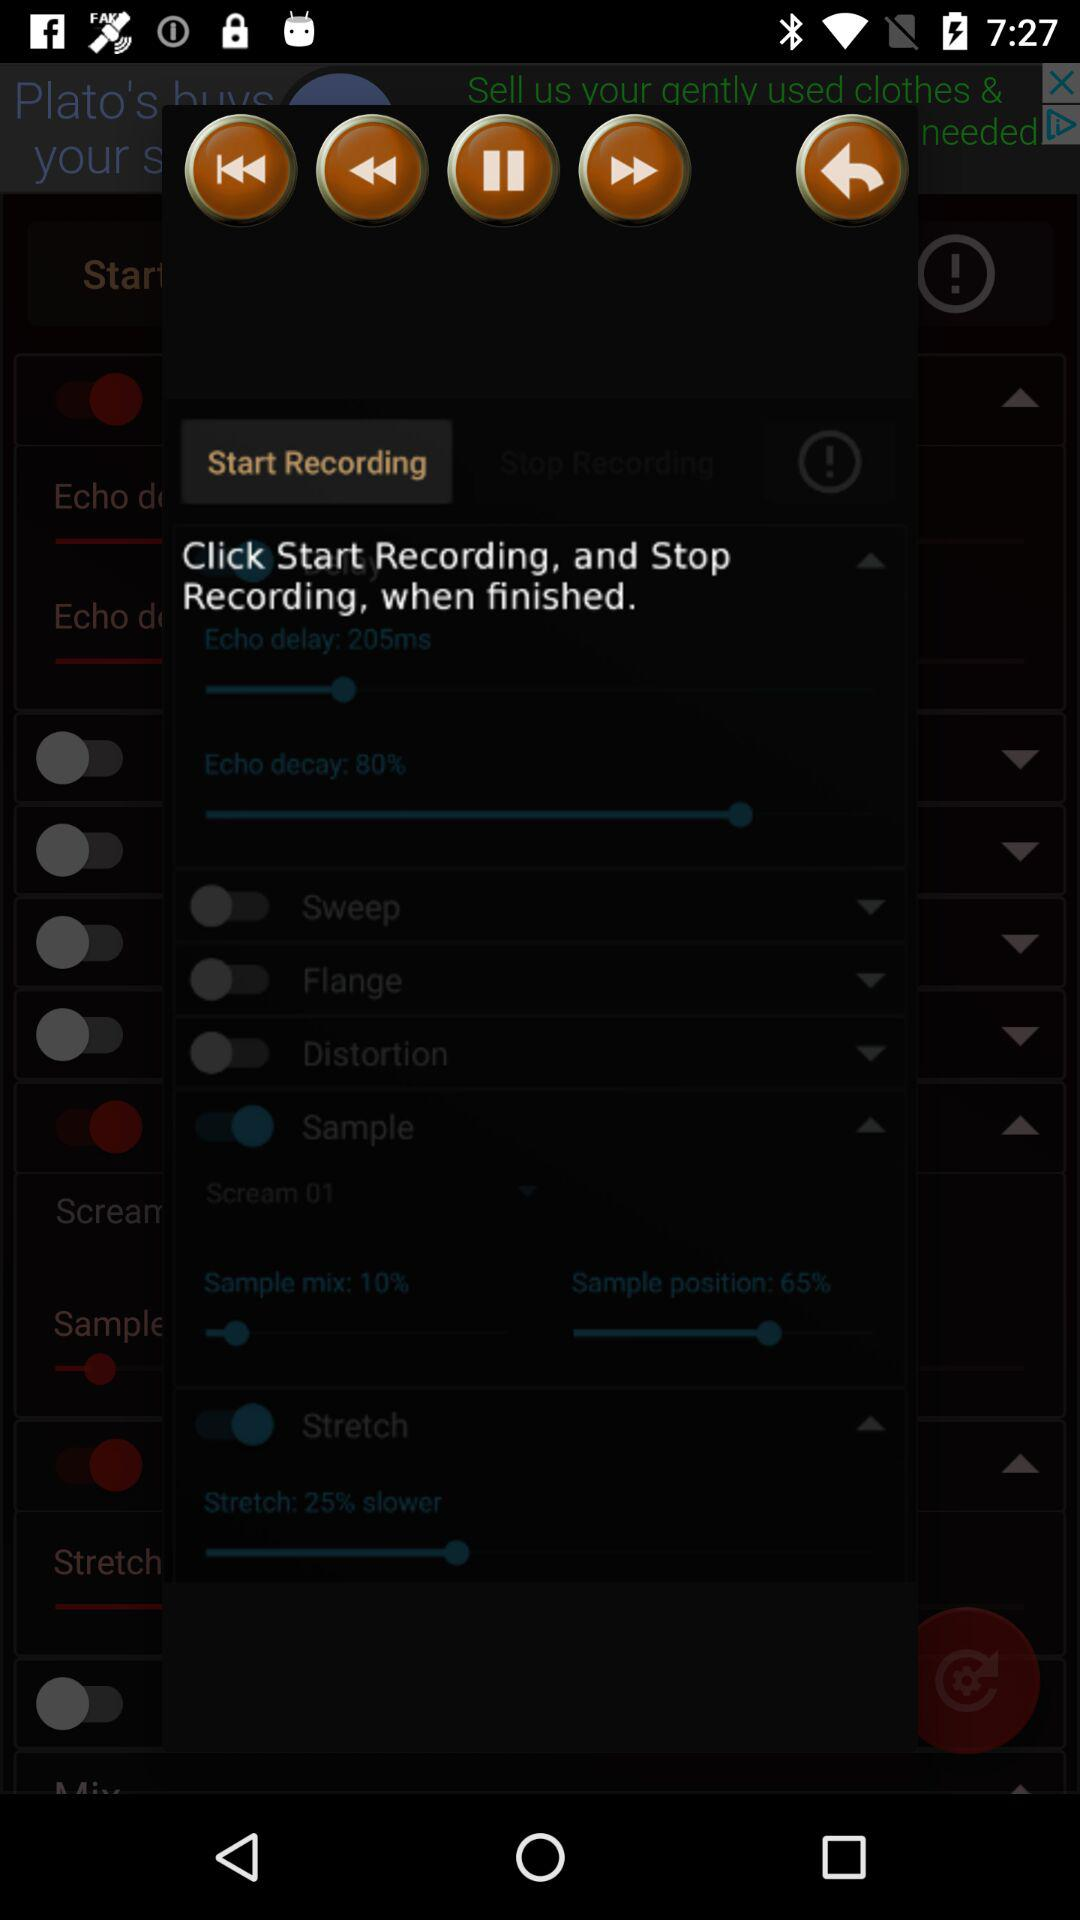How much of the recording is stretched? The recording is stretched by 25% slower. 